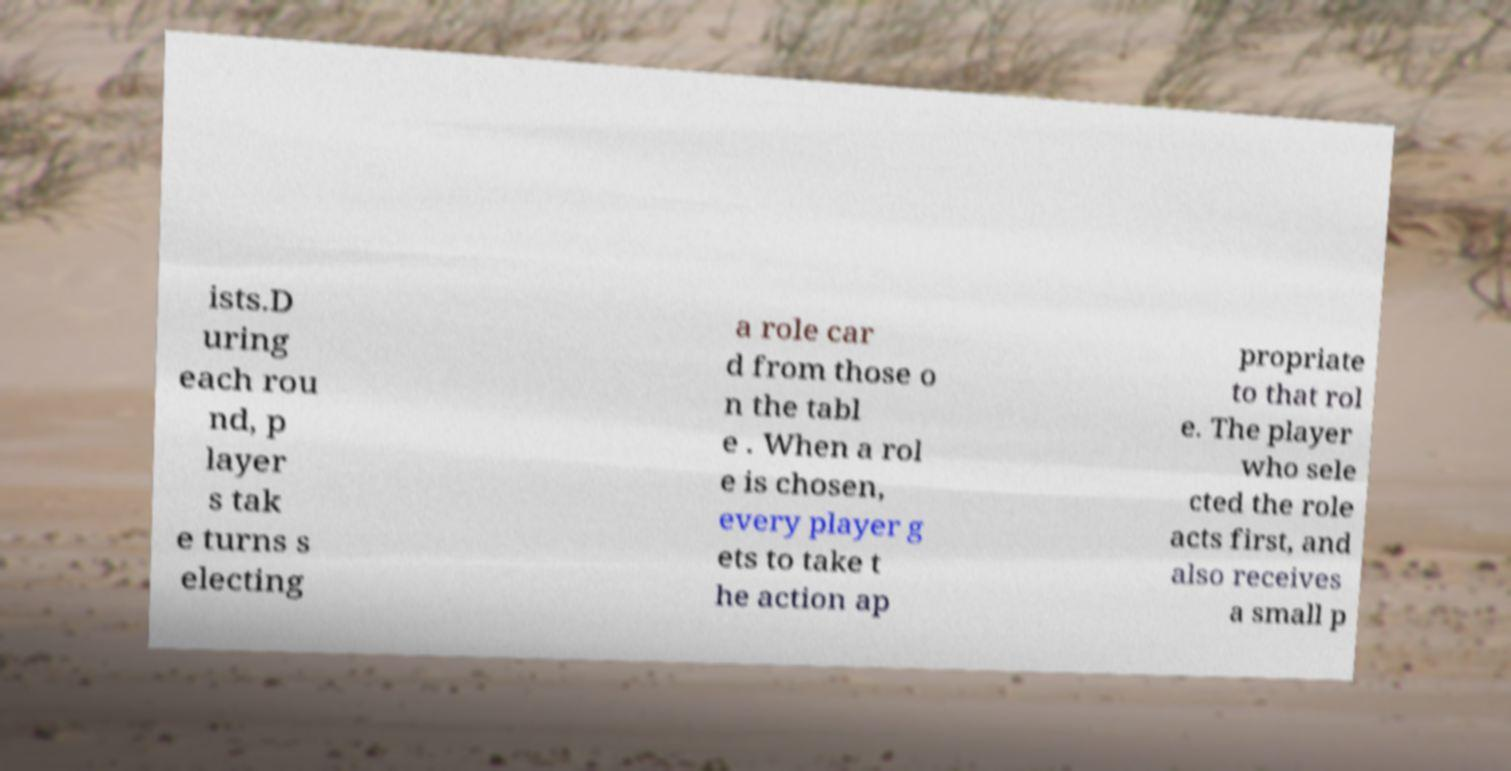Can you read and provide the text displayed in the image?This photo seems to have some interesting text. Can you extract and type it out for me? ists.D uring each rou nd, p layer s tak e turns s electing a role car d from those o n the tabl e . When a rol e is chosen, every player g ets to take t he action ap propriate to that rol e. The player who sele cted the role acts first, and also receives a small p 